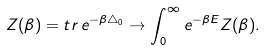<formula> <loc_0><loc_0><loc_500><loc_500>Z ( \beta ) = t r \, e ^ { - \beta \triangle _ { 0 } } \rightarrow \int _ { 0 } ^ { \infty } e ^ { - \beta E } Z ( \beta ) .</formula> 